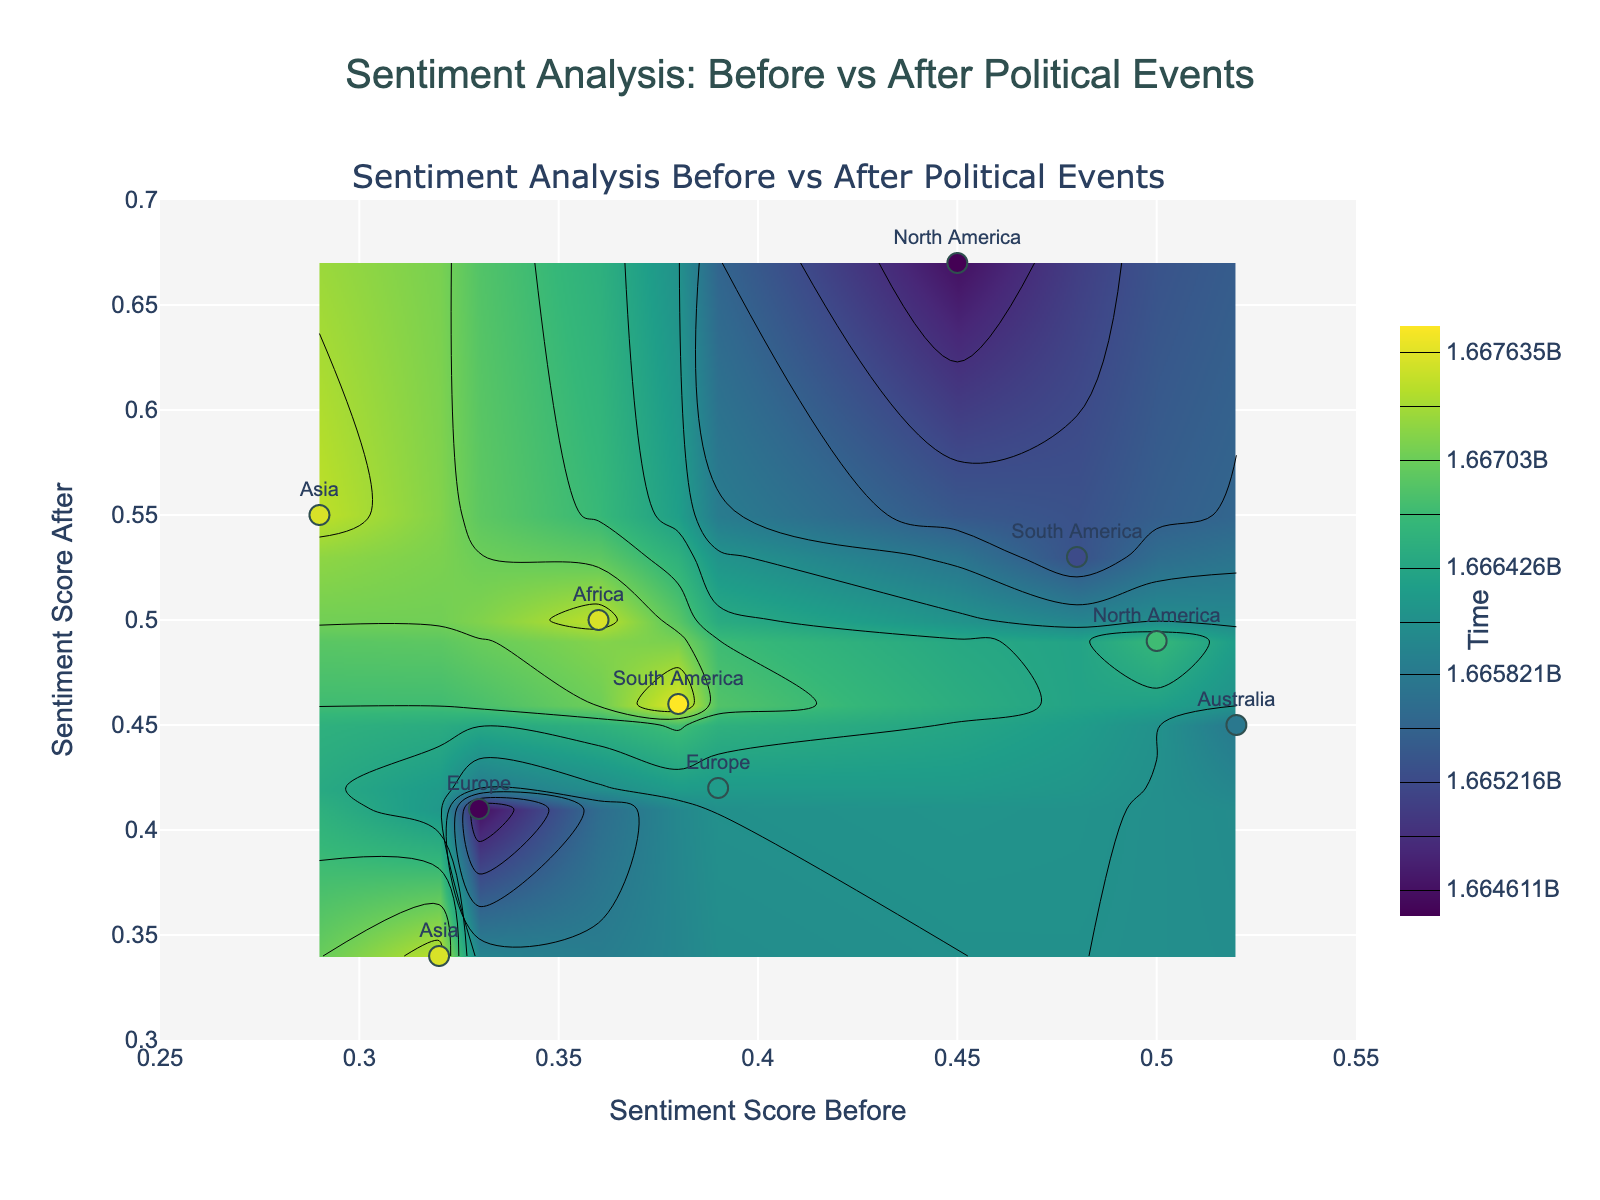What's the title of the plot? The title is usually displayed prominently at the top of the figure. In this case, it should be visible in large font at the center-top of the plot.
Answer: Sentiment Analysis: Before vs After Political Events How many data points are visualized in the figure? Each data point represents a region with a scatter plot marker. By counting the number of these markers, we can determine the number of data points.
Answer: 10 Which region has the highest sentiment score before the event? Look for the highest value on the x-axis and find the corresponding data point's region label.
Answer: Australia Which region has the lowest sentiment score after the event? Look for the lowest value on the y-axis and identify the corresponding data point's region label.
Answer: Asia (Japan Diet Session on Defense Policy) What is the difference in sentiment score before and after the Australian Federal Budget Release? Find the Australian Federal Budget Release data point, check the x (before) and y (after) values, and calculate the difference.
Answer: -0.07 Did South America's sentiment score change positively or negatively after political events? Identify data points associated with South America on the scatter plot. Compare x and y values to see if they increased, decreased, or remained unchanged.
Answer: Positively Which event seems to have the most significant positive impact on sentiment scores? Evaluate the distance between x and y coordinates where the y-coordinate is significantly higher than the x-coordinate.
Answer: Indian General Election Announcement Is there a region where the sentiment score decreased after the political event? Check if the y-coordinate (after) is less than the x-coordinate (before) for any data point.
Answer: Yes (Australia: Australian Federal Budget Release) What's the color used to represent the data points' markers? Observe the color scheme used for the scatter plot markers, which follows the 'Viridis' colorscale in this case.
Answer: A gradient of colors from the 'Viridis' scheme How are the contour colors mapped in relation to time? Identify the color bar legend, which should indicate how colors correspond to different times (Unix timestamp values).
Answer: Colors transition from darker to lighter shades based on the timestamp, from early to later dates 